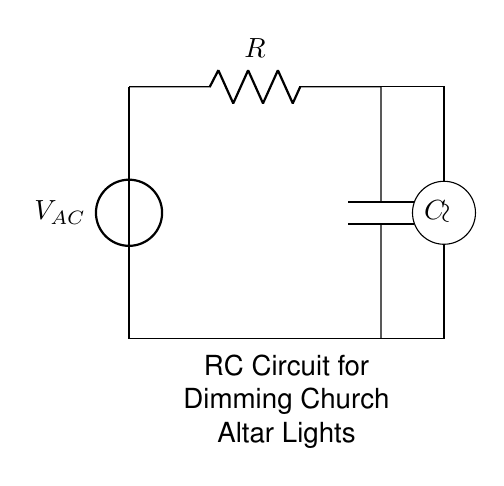What is the main purpose of the circuit? The RC circuit is designed for dimming church altar lights, which is indicated by the label beneath the circuit.
Answer: Dimming lights What type of source is used in the circuit? The circuit uses an AC voltage source, as indicated by the designation V_AC.
Answer: AC voltage source How many components are in the circuit? The circuit consists of three components: one resistor, one capacitor, and one voltage source. This can be counted directly from the diagram.
Answer: Three What component is responsible for storing energy? The capacitor is the component that stores energy in the circuit, which is its primary function.
Answer: Capacitor What is the relationship between resistance and light dimming? Increasing the resistance generally decreases the current flowing through the circuit, which results in lower light intensity, thus dimming the lights.
Answer: Inverse relationship What happens to the time constant as the resistance increases? The time constant of an RC circuit is calculated as the product of resistance and capacitance. Increasing resistance will increase the time constant, affecting the charging and discharging rates of the capacitor.
Answer: It increases What would a higher capacitance do to the dimming effect? A higher capacitance leads to a longer time constant and slower changes in light intensity, resulting in smoother dimming transitions.
Answer: Smoother dimming 